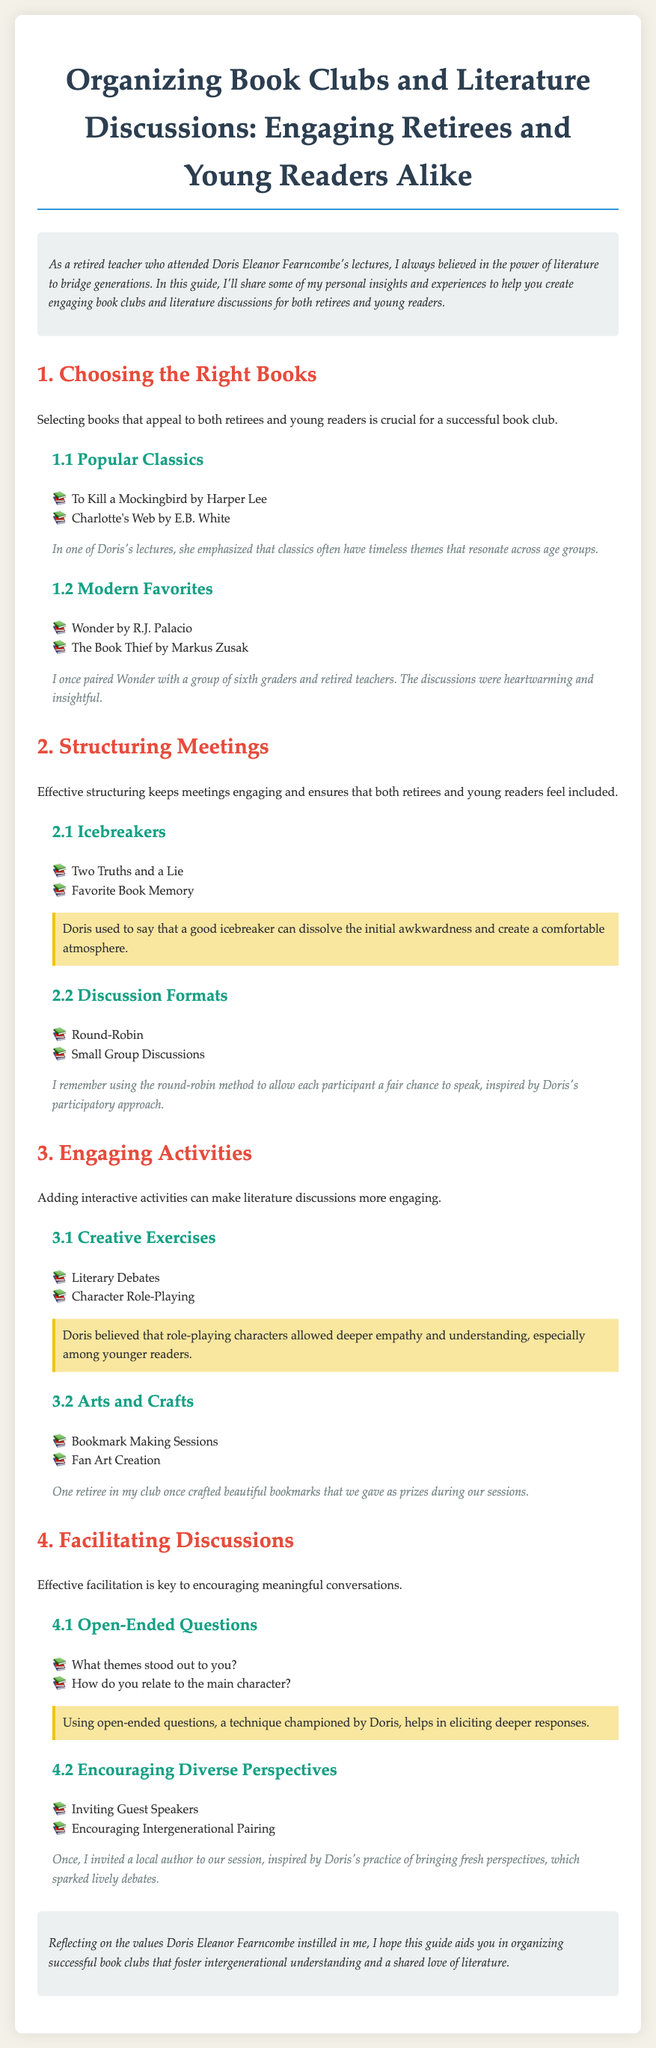what is the title of the guide? The title is provided at the top of the document, which describes the focus of the guide.
Answer: Organizing Book Clubs and Literature Discussions: Engaging Retirees and Young Readers Alike who emphasized the importance of icebreakers? The guide mentions that Doris used to promote the use of icebreakers, highlighting their role in meetings.
Answer: Doris what type of books are suggested in section 1? The section focuses on books that appeal to both retirees and young readers, categorizing them into types.
Answer: Popular Classics and Modern Favorites how many icebreaker activities are listed? The document provides a specific number of icebreaker activities within the relevant section.
Answer: 2 which book is mentioned as a popular classic by Harper Lee? The guide lists specific classics, naming the book and its author.
Answer: To Kill a Mockingbird what activity involves creating art related to the book? The document suggests a particular activity associated with creativity and interaction among members.
Answer: Fan Art Creation what is the purpose of open-ended questions in discussions? The guide explains the use of open-ended questions as a technique for facilitating deeper conversation.
Answer: Eliciting deeper responses how many subsections are in the section about structuring meetings? The number of subsections indicates the structured approach to the topic discussed.
Answer: 2 